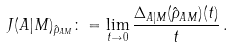<formula> <loc_0><loc_0><loc_500><loc_500>J ( A | M ) _ { \hat { \rho } _ { A M } } \colon = \lim _ { t \to 0 } \frac { \Delta _ { A | M } ( \hat { \rho } _ { A M } ) ( t ) } { t } \, .</formula> 